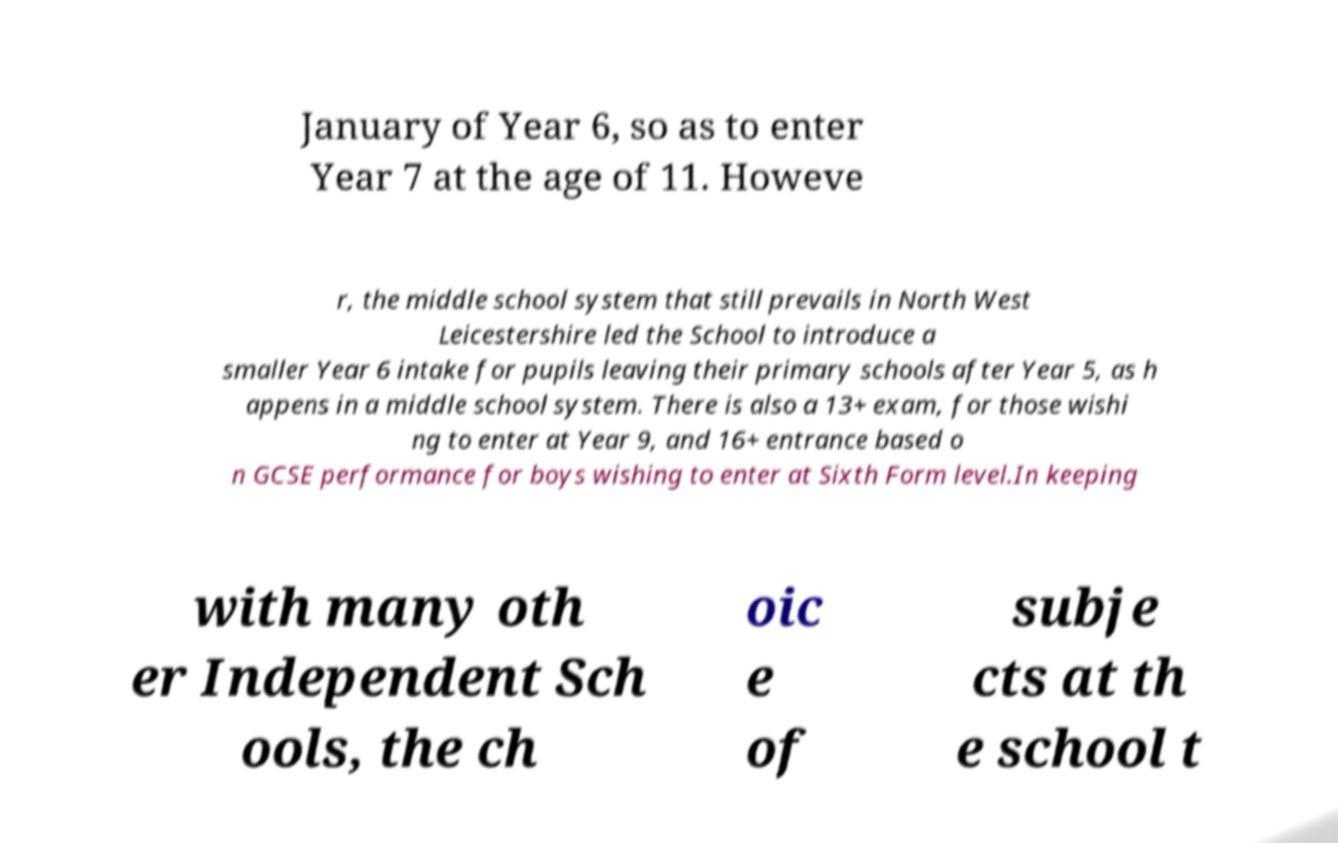There's text embedded in this image that I need extracted. Can you transcribe it verbatim? January of Year 6, so as to enter Year 7 at the age of 11. Howeve r, the middle school system that still prevails in North West Leicestershire led the School to introduce a smaller Year 6 intake for pupils leaving their primary schools after Year 5, as h appens in a middle school system. There is also a 13+ exam, for those wishi ng to enter at Year 9, and 16+ entrance based o n GCSE performance for boys wishing to enter at Sixth Form level.In keeping with many oth er Independent Sch ools, the ch oic e of subje cts at th e school t 